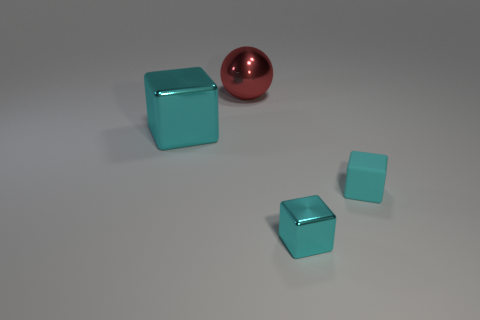What number of things are both to the right of the small cyan metallic block and behind the big shiny block?
Your answer should be compact. 0. How many other things are the same size as the red shiny object?
Keep it short and to the point. 1. The thing that is behind the small matte object and in front of the red ball is made of what material?
Provide a succinct answer. Metal. Do the large ball and the object in front of the tiny matte object have the same color?
Ensure brevity in your answer.  No. What is the size of the cyan rubber thing that is the same shape as the small metal thing?
Keep it short and to the point. Small. What shape is the cyan object that is to the left of the rubber object and on the right side of the ball?
Give a very brief answer. Cube. Does the red shiny object have the same size as the thing that is to the left of the big metallic ball?
Provide a succinct answer. Yes. There is a tiny metallic object that is the same shape as the cyan matte thing; what is its color?
Keep it short and to the point. Cyan. Does the object behind the large cube have the same size as the cyan block that is in front of the small cyan matte thing?
Give a very brief answer. No. Is the tiny cyan metallic object the same shape as the red metal thing?
Provide a short and direct response. No. 